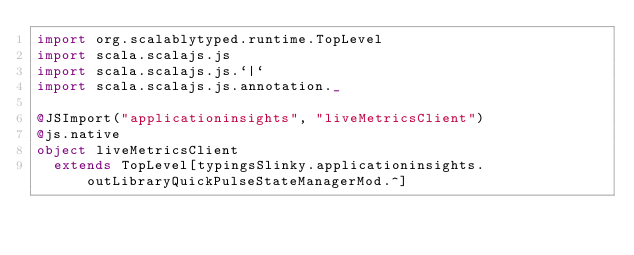<code> <loc_0><loc_0><loc_500><loc_500><_Scala_>import org.scalablytyped.runtime.TopLevel
import scala.scalajs.js
import scala.scalajs.js.`|`
import scala.scalajs.js.annotation._

@JSImport("applicationinsights", "liveMetricsClient")
@js.native
object liveMetricsClient
  extends TopLevel[typingsSlinky.applicationinsights.outLibraryQuickPulseStateManagerMod.^]

</code> 